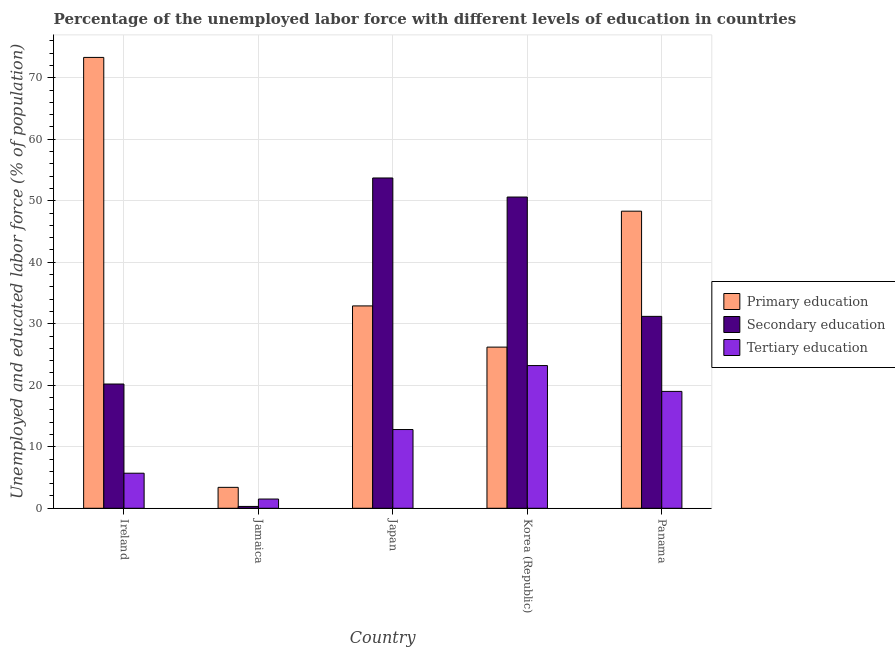How many groups of bars are there?
Make the answer very short. 5. Are the number of bars per tick equal to the number of legend labels?
Your answer should be compact. Yes. How many bars are there on the 2nd tick from the left?
Offer a very short reply. 3. How many bars are there on the 4th tick from the right?
Offer a very short reply. 3. What is the label of the 2nd group of bars from the left?
Give a very brief answer. Jamaica. In how many cases, is the number of bars for a given country not equal to the number of legend labels?
Ensure brevity in your answer.  0. What is the percentage of labor force who received secondary education in Ireland?
Ensure brevity in your answer.  20.2. Across all countries, what is the maximum percentage of labor force who received primary education?
Ensure brevity in your answer.  73.3. Across all countries, what is the minimum percentage of labor force who received tertiary education?
Offer a terse response. 1.5. In which country was the percentage of labor force who received primary education maximum?
Give a very brief answer. Ireland. In which country was the percentage of labor force who received primary education minimum?
Make the answer very short. Jamaica. What is the total percentage of labor force who received secondary education in the graph?
Provide a short and direct response. 156. What is the difference between the percentage of labor force who received primary education in Jamaica and that in Japan?
Ensure brevity in your answer.  -29.5. What is the difference between the percentage of labor force who received primary education in Japan and the percentage of labor force who received secondary education in Ireland?
Keep it short and to the point. 12.7. What is the average percentage of labor force who received secondary education per country?
Provide a succinct answer. 31.2. What is the difference between the percentage of labor force who received tertiary education and percentage of labor force who received secondary education in Japan?
Ensure brevity in your answer.  -40.9. In how many countries, is the percentage of labor force who received tertiary education greater than 38 %?
Ensure brevity in your answer.  0. What is the ratio of the percentage of labor force who received primary education in Jamaica to that in Korea (Republic)?
Offer a terse response. 0.13. Is the percentage of labor force who received primary education in Ireland less than that in Korea (Republic)?
Make the answer very short. No. What is the difference between the highest and the second highest percentage of labor force who received tertiary education?
Your response must be concise. 4.2. What is the difference between the highest and the lowest percentage of labor force who received secondary education?
Your answer should be compact. 53.4. Is the sum of the percentage of labor force who received primary education in Ireland and Jamaica greater than the maximum percentage of labor force who received tertiary education across all countries?
Keep it short and to the point. Yes. What does the 2nd bar from the left in Ireland represents?
Provide a short and direct response. Secondary education. What does the 3rd bar from the right in Panama represents?
Provide a short and direct response. Primary education. How many bars are there?
Make the answer very short. 15. Are all the bars in the graph horizontal?
Provide a short and direct response. No. How many countries are there in the graph?
Give a very brief answer. 5. What is the difference between two consecutive major ticks on the Y-axis?
Offer a very short reply. 10. Are the values on the major ticks of Y-axis written in scientific E-notation?
Make the answer very short. No. Does the graph contain any zero values?
Give a very brief answer. No. Does the graph contain grids?
Provide a succinct answer. Yes. How many legend labels are there?
Keep it short and to the point. 3. What is the title of the graph?
Provide a succinct answer. Percentage of the unemployed labor force with different levels of education in countries. Does "Ages 15-20" appear as one of the legend labels in the graph?
Your response must be concise. No. What is the label or title of the Y-axis?
Your answer should be compact. Unemployed and educated labor force (% of population). What is the Unemployed and educated labor force (% of population) of Primary education in Ireland?
Your answer should be very brief. 73.3. What is the Unemployed and educated labor force (% of population) in Secondary education in Ireland?
Ensure brevity in your answer.  20.2. What is the Unemployed and educated labor force (% of population) in Tertiary education in Ireland?
Keep it short and to the point. 5.7. What is the Unemployed and educated labor force (% of population) in Primary education in Jamaica?
Provide a succinct answer. 3.4. What is the Unemployed and educated labor force (% of population) in Secondary education in Jamaica?
Your response must be concise. 0.3. What is the Unemployed and educated labor force (% of population) in Primary education in Japan?
Ensure brevity in your answer.  32.9. What is the Unemployed and educated labor force (% of population) of Secondary education in Japan?
Make the answer very short. 53.7. What is the Unemployed and educated labor force (% of population) in Tertiary education in Japan?
Ensure brevity in your answer.  12.8. What is the Unemployed and educated labor force (% of population) in Primary education in Korea (Republic)?
Offer a terse response. 26.2. What is the Unemployed and educated labor force (% of population) of Secondary education in Korea (Republic)?
Offer a terse response. 50.6. What is the Unemployed and educated labor force (% of population) in Tertiary education in Korea (Republic)?
Make the answer very short. 23.2. What is the Unemployed and educated labor force (% of population) of Primary education in Panama?
Provide a short and direct response. 48.3. What is the Unemployed and educated labor force (% of population) of Secondary education in Panama?
Make the answer very short. 31.2. What is the Unemployed and educated labor force (% of population) in Tertiary education in Panama?
Your response must be concise. 19. Across all countries, what is the maximum Unemployed and educated labor force (% of population) of Primary education?
Give a very brief answer. 73.3. Across all countries, what is the maximum Unemployed and educated labor force (% of population) in Secondary education?
Your answer should be very brief. 53.7. Across all countries, what is the maximum Unemployed and educated labor force (% of population) in Tertiary education?
Offer a very short reply. 23.2. Across all countries, what is the minimum Unemployed and educated labor force (% of population) of Primary education?
Offer a very short reply. 3.4. Across all countries, what is the minimum Unemployed and educated labor force (% of population) in Secondary education?
Your answer should be very brief. 0.3. Across all countries, what is the minimum Unemployed and educated labor force (% of population) of Tertiary education?
Give a very brief answer. 1.5. What is the total Unemployed and educated labor force (% of population) in Primary education in the graph?
Provide a short and direct response. 184.1. What is the total Unemployed and educated labor force (% of population) of Secondary education in the graph?
Your answer should be very brief. 156. What is the total Unemployed and educated labor force (% of population) of Tertiary education in the graph?
Ensure brevity in your answer.  62.2. What is the difference between the Unemployed and educated labor force (% of population) of Primary education in Ireland and that in Jamaica?
Your answer should be very brief. 69.9. What is the difference between the Unemployed and educated labor force (% of population) of Secondary education in Ireland and that in Jamaica?
Your answer should be very brief. 19.9. What is the difference between the Unemployed and educated labor force (% of population) in Primary education in Ireland and that in Japan?
Offer a terse response. 40.4. What is the difference between the Unemployed and educated labor force (% of population) of Secondary education in Ireland and that in Japan?
Keep it short and to the point. -33.5. What is the difference between the Unemployed and educated labor force (% of population) of Tertiary education in Ireland and that in Japan?
Your response must be concise. -7.1. What is the difference between the Unemployed and educated labor force (% of population) in Primary education in Ireland and that in Korea (Republic)?
Your response must be concise. 47.1. What is the difference between the Unemployed and educated labor force (% of population) in Secondary education in Ireland and that in Korea (Republic)?
Provide a short and direct response. -30.4. What is the difference between the Unemployed and educated labor force (% of population) of Tertiary education in Ireland and that in Korea (Republic)?
Ensure brevity in your answer.  -17.5. What is the difference between the Unemployed and educated labor force (% of population) in Primary education in Ireland and that in Panama?
Your answer should be very brief. 25. What is the difference between the Unemployed and educated labor force (% of population) in Primary education in Jamaica and that in Japan?
Provide a succinct answer. -29.5. What is the difference between the Unemployed and educated labor force (% of population) in Secondary education in Jamaica and that in Japan?
Ensure brevity in your answer.  -53.4. What is the difference between the Unemployed and educated labor force (% of population) in Tertiary education in Jamaica and that in Japan?
Ensure brevity in your answer.  -11.3. What is the difference between the Unemployed and educated labor force (% of population) of Primary education in Jamaica and that in Korea (Republic)?
Your answer should be very brief. -22.8. What is the difference between the Unemployed and educated labor force (% of population) of Secondary education in Jamaica and that in Korea (Republic)?
Your response must be concise. -50.3. What is the difference between the Unemployed and educated labor force (% of population) of Tertiary education in Jamaica and that in Korea (Republic)?
Provide a short and direct response. -21.7. What is the difference between the Unemployed and educated labor force (% of population) in Primary education in Jamaica and that in Panama?
Give a very brief answer. -44.9. What is the difference between the Unemployed and educated labor force (% of population) of Secondary education in Jamaica and that in Panama?
Provide a succinct answer. -30.9. What is the difference between the Unemployed and educated labor force (% of population) in Tertiary education in Jamaica and that in Panama?
Make the answer very short. -17.5. What is the difference between the Unemployed and educated labor force (% of population) in Primary education in Japan and that in Panama?
Your answer should be very brief. -15.4. What is the difference between the Unemployed and educated labor force (% of population) of Tertiary education in Japan and that in Panama?
Provide a short and direct response. -6.2. What is the difference between the Unemployed and educated labor force (% of population) in Primary education in Korea (Republic) and that in Panama?
Your answer should be very brief. -22.1. What is the difference between the Unemployed and educated labor force (% of population) of Tertiary education in Korea (Republic) and that in Panama?
Keep it short and to the point. 4.2. What is the difference between the Unemployed and educated labor force (% of population) of Primary education in Ireland and the Unemployed and educated labor force (% of population) of Tertiary education in Jamaica?
Your answer should be very brief. 71.8. What is the difference between the Unemployed and educated labor force (% of population) in Secondary education in Ireland and the Unemployed and educated labor force (% of population) in Tertiary education in Jamaica?
Offer a very short reply. 18.7. What is the difference between the Unemployed and educated labor force (% of population) in Primary education in Ireland and the Unemployed and educated labor force (% of population) in Secondary education in Japan?
Provide a short and direct response. 19.6. What is the difference between the Unemployed and educated labor force (% of population) in Primary education in Ireland and the Unemployed and educated labor force (% of population) in Tertiary education in Japan?
Make the answer very short. 60.5. What is the difference between the Unemployed and educated labor force (% of population) of Primary education in Ireland and the Unemployed and educated labor force (% of population) of Secondary education in Korea (Republic)?
Provide a short and direct response. 22.7. What is the difference between the Unemployed and educated labor force (% of population) of Primary education in Ireland and the Unemployed and educated labor force (% of population) of Tertiary education in Korea (Republic)?
Your answer should be very brief. 50.1. What is the difference between the Unemployed and educated labor force (% of population) in Primary education in Ireland and the Unemployed and educated labor force (% of population) in Secondary education in Panama?
Ensure brevity in your answer.  42.1. What is the difference between the Unemployed and educated labor force (% of population) in Primary education in Ireland and the Unemployed and educated labor force (% of population) in Tertiary education in Panama?
Provide a short and direct response. 54.3. What is the difference between the Unemployed and educated labor force (% of population) of Primary education in Jamaica and the Unemployed and educated labor force (% of population) of Secondary education in Japan?
Give a very brief answer. -50.3. What is the difference between the Unemployed and educated labor force (% of population) of Secondary education in Jamaica and the Unemployed and educated labor force (% of population) of Tertiary education in Japan?
Offer a very short reply. -12.5. What is the difference between the Unemployed and educated labor force (% of population) in Primary education in Jamaica and the Unemployed and educated labor force (% of population) in Secondary education in Korea (Republic)?
Ensure brevity in your answer.  -47.2. What is the difference between the Unemployed and educated labor force (% of population) in Primary education in Jamaica and the Unemployed and educated labor force (% of population) in Tertiary education in Korea (Republic)?
Ensure brevity in your answer.  -19.8. What is the difference between the Unemployed and educated labor force (% of population) in Secondary education in Jamaica and the Unemployed and educated labor force (% of population) in Tertiary education in Korea (Republic)?
Ensure brevity in your answer.  -22.9. What is the difference between the Unemployed and educated labor force (% of population) in Primary education in Jamaica and the Unemployed and educated labor force (% of population) in Secondary education in Panama?
Your response must be concise. -27.8. What is the difference between the Unemployed and educated labor force (% of population) of Primary education in Jamaica and the Unemployed and educated labor force (% of population) of Tertiary education in Panama?
Your answer should be compact. -15.6. What is the difference between the Unemployed and educated labor force (% of population) of Secondary education in Jamaica and the Unemployed and educated labor force (% of population) of Tertiary education in Panama?
Offer a terse response. -18.7. What is the difference between the Unemployed and educated labor force (% of population) in Primary education in Japan and the Unemployed and educated labor force (% of population) in Secondary education in Korea (Republic)?
Your answer should be compact. -17.7. What is the difference between the Unemployed and educated labor force (% of population) in Secondary education in Japan and the Unemployed and educated labor force (% of population) in Tertiary education in Korea (Republic)?
Your answer should be compact. 30.5. What is the difference between the Unemployed and educated labor force (% of population) in Secondary education in Japan and the Unemployed and educated labor force (% of population) in Tertiary education in Panama?
Offer a very short reply. 34.7. What is the difference between the Unemployed and educated labor force (% of population) in Secondary education in Korea (Republic) and the Unemployed and educated labor force (% of population) in Tertiary education in Panama?
Provide a short and direct response. 31.6. What is the average Unemployed and educated labor force (% of population) in Primary education per country?
Your answer should be compact. 36.82. What is the average Unemployed and educated labor force (% of population) of Secondary education per country?
Ensure brevity in your answer.  31.2. What is the average Unemployed and educated labor force (% of population) of Tertiary education per country?
Make the answer very short. 12.44. What is the difference between the Unemployed and educated labor force (% of population) in Primary education and Unemployed and educated labor force (% of population) in Secondary education in Ireland?
Provide a succinct answer. 53.1. What is the difference between the Unemployed and educated labor force (% of population) of Primary education and Unemployed and educated labor force (% of population) of Tertiary education in Ireland?
Provide a short and direct response. 67.6. What is the difference between the Unemployed and educated labor force (% of population) in Secondary education and Unemployed and educated labor force (% of population) in Tertiary education in Ireland?
Offer a terse response. 14.5. What is the difference between the Unemployed and educated labor force (% of population) in Secondary education and Unemployed and educated labor force (% of population) in Tertiary education in Jamaica?
Ensure brevity in your answer.  -1.2. What is the difference between the Unemployed and educated labor force (% of population) in Primary education and Unemployed and educated labor force (% of population) in Secondary education in Japan?
Your response must be concise. -20.8. What is the difference between the Unemployed and educated labor force (% of population) in Primary education and Unemployed and educated labor force (% of population) in Tertiary education in Japan?
Ensure brevity in your answer.  20.1. What is the difference between the Unemployed and educated labor force (% of population) in Secondary education and Unemployed and educated labor force (% of population) in Tertiary education in Japan?
Provide a succinct answer. 40.9. What is the difference between the Unemployed and educated labor force (% of population) in Primary education and Unemployed and educated labor force (% of population) in Secondary education in Korea (Republic)?
Your answer should be compact. -24.4. What is the difference between the Unemployed and educated labor force (% of population) in Secondary education and Unemployed and educated labor force (% of population) in Tertiary education in Korea (Republic)?
Ensure brevity in your answer.  27.4. What is the difference between the Unemployed and educated labor force (% of population) of Primary education and Unemployed and educated labor force (% of population) of Tertiary education in Panama?
Give a very brief answer. 29.3. What is the ratio of the Unemployed and educated labor force (% of population) of Primary education in Ireland to that in Jamaica?
Your response must be concise. 21.56. What is the ratio of the Unemployed and educated labor force (% of population) of Secondary education in Ireland to that in Jamaica?
Make the answer very short. 67.33. What is the ratio of the Unemployed and educated labor force (% of population) in Tertiary education in Ireland to that in Jamaica?
Your answer should be very brief. 3.8. What is the ratio of the Unemployed and educated labor force (% of population) of Primary education in Ireland to that in Japan?
Your answer should be compact. 2.23. What is the ratio of the Unemployed and educated labor force (% of population) of Secondary education in Ireland to that in Japan?
Your answer should be very brief. 0.38. What is the ratio of the Unemployed and educated labor force (% of population) in Tertiary education in Ireland to that in Japan?
Give a very brief answer. 0.45. What is the ratio of the Unemployed and educated labor force (% of population) of Primary education in Ireland to that in Korea (Republic)?
Your response must be concise. 2.8. What is the ratio of the Unemployed and educated labor force (% of population) in Secondary education in Ireland to that in Korea (Republic)?
Keep it short and to the point. 0.4. What is the ratio of the Unemployed and educated labor force (% of population) in Tertiary education in Ireland to that in Korea (Republic)?
Your answer should be compact. 0.25. What is the ratio of the Unemployed and educated labor force (% of population) in Primary education in Ireland to that in Panama?
Ensure brevity in your answer.  1.52. What is the ratio of the Unemployed and educated labor force (% of population) of Secondary education in Ireland to that in Panama?
Offer a very short reply. 0.65. What is the ratio of the Unemployed and educated labor force (% of population) of Primary education in Jamaica to that in Japan?
Give a very brief answer. 0.1. What is the ratio of the Unemployed and educated labor force (% of population) in Secondary education in Jamaica to that in Japan?
Provide a short and direct response. 0.01. What is the ratio of the Unemployed and educated labor force (% of population) of Tertiary education in Jamaica to that in Japan?
Keep it short and to the point. 0.12. What is the ratio of the Unemployed and educated labor force (% of population) of Primary education in Jamaica to that in Korea (Republic)?
Provide a short and direct response. 0.13. What is the ratio of the Unemployed and educated labor force (% of population) of Secondary education in Jamaica to that in Korea (Republic)?
Offer a very short reply. 0.01. What is the ratio of the Unemployed and educated labor force (% of population) in Tertiary education in Jamaica to that in Korea (Republic)?
Keep it short and to the point. 0.06. What is the ratio of the Unemployed and educated labor force (% of population) in Primary education in Jamaica to that in Panama?
Your response must be concise. 0.07. What is the ratio of the Unemployed and educated labor force (% of population) of Secondary education in Jamaica to that in Panama?
Your response must be concise. 0.01. What is the ratio of the Unemployed and educated labor force (% of population) in Tertiary education in Jamaica to that in Panama?
Offer a very short reply. 0.08. What is the ratio of the Unemployed and educated labor force (% of population) in Primary education in Japan to that in Korea (Republic)?
Offer a very short reply. 1.26. What is the ratio of the Unemployed and educated labor force (% of population) of Secondary education in Japan to that in Korea (Republic)?
Your answer should be very brief. 1.06. What is the ratio of the Unemployed and educated labor force (% of population) in Tertiary education in Japan to that in Korea (Republic)?
Give a very brief answer. 0.55. What is the ratio of the Unemployed and educated labor force (% of population) in Primary education in Japan to that in Panama?
Your response must be concise. 0.68. What is the ratio of the Unemployed and educated labor force (% of population) in Secondary education in Japan to that in Panama?
Your response must be concise. 1.72. What is the ratio of the Unemployed and educated labor force (% of population) in Tertiary education in Japan to that in Panama?
Provide a short and direct response. 0.67. What is the ratio of the Unemployed and educated labor force (% of population) in Primary education in Korea (Republic) to that in Panama?
Offer a terse response. 0.54. What is the ratio of the Unemployed and educated labor force (% of population) in Secondary education in Korea (Republic) to that in Panama?
Provide a short and direct response. 1.62. What is the ratio of the Unemployed and educated labor force (% of population) in Tertiary education in Korea (Republic) to that in Panama?
Provide a short and direct response. 1.22. What is the difference between the highest and the second highest Unemployed and educated labor force (% of population) of Secondary education?
Ensure brevity in your answer.  3.1. What is the difference between the highest and the lowest Unemployed and educated labor force (% of population) in Primary education?
Offer a very short reply. 69.9. What is the difference between the highest and the lowest Unemployed and educated labor force (% of population) of Secondary education?
Ensure brevity in your answer.  53.4. What is the difference between the highest and the lowest Unemployed and educated labor force (% of population) of Tertiary education?
Provide a short and direct response. 21.7. 